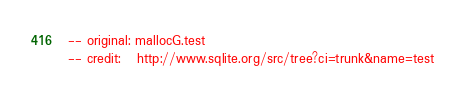<code> <loc_0><loc_0><loc_500><loc_500><_SQL_>-- original: mallocG.test
-- credit:   http://www.sqlite.org/src/tree?ci=trunk&name=test
</code> 